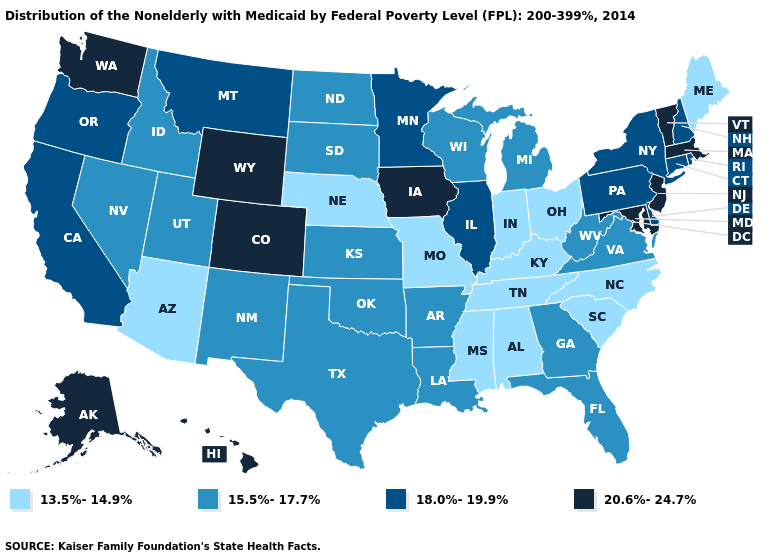Does Rhode Island have the lowest value in the Northeast?
Write a very short answer. No. Which states hav the highest value in the West?
Write a very short answer. Alaska, Colorado, Hawaii, Washington, Wyoming. Does Montana have the lowest value in the West?
Keep it brief. No. What is the value of Virginia?
Short answer required. 15.5%-17.7%. Among the states that border New Mexico , does Utah have the lowest value?
Concise answer only. No. What is the value of Wisconsin?
Write a very short answer. 15.5%-17.7%. Name the states that have a value in the range 15.5%-17.7%?
Write a very short answer. Arkansas, Florida, Georgia, Idaho, Kansas, Louisiana, Michigan, Nevada, New Mexico, North Dakota, Oklahoma, South Dakota, Texas, Utah, Virginia, West Virginia, Wisconsin. Among the states that border West Virginia , which have the lowest value?
Keep it brief. Kentucky, Ohio. Among the states that border Idaho , which have the lowest value?
Give a very brief answer. Nevada, Utah. What is the lowest value in states that border Massachusetts?
Write a very short answer. 18.0%-19.9%. What is the highest value in the MidWest ?
Give a very brief answer. 20.6%-24.7%. Does Missouri have the lowest value in the USA?
Short answer required. Yes. Among the states that border Wyoming , does Montana have the highest value?
Quick response, please. No. What is the highest value in the USA?
Short answer required. 20.6%-24.7%. 